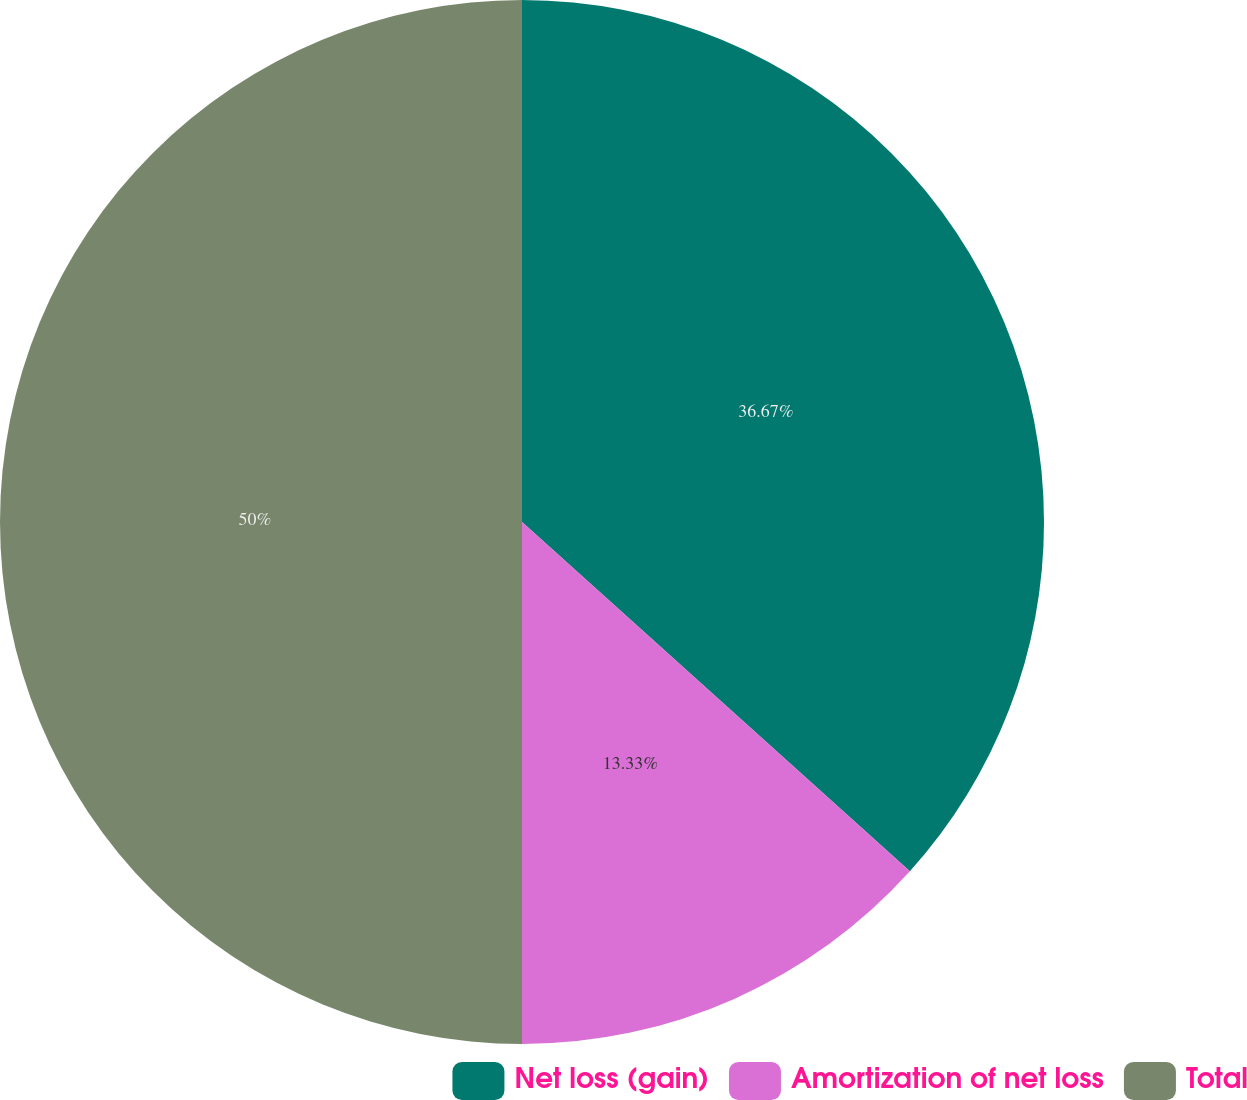<chart> <loc_0><loc_0><loc_500><loc_500><pie_chart><fcel>Net loss (gain)<fcel>Amortization of net loss<fcel>Total<nl><fcel>36.67%<fcel>13.33%<fcel>50.0%<nl></chart> 